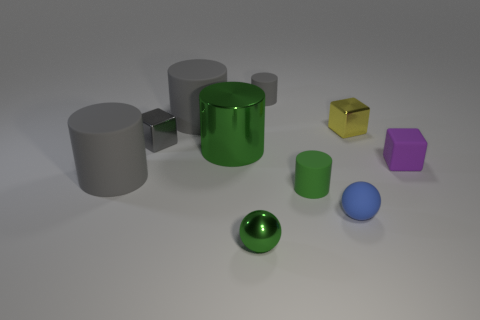Subtract all brown balls. How many gray cylinders are left? 3 Subtract all large gray matte cylinders. How many cylinders are left? 3 Subtract all cyan cylinders. Subtract all gray balls. How many cylinders are left? 5 Subtract all cubes. How many objects are left? 7 Subtract all small gray objects. Subtract all tiny blue metallic balls. How many objects are left? 8 Add 9 tiny blue matte things. How many tiny blue matte things are left? 10 Add 2 metallic spheres. How many metallic spheres exist? 3 Subtract 0 yellow cylinders. How many objects are left? 10 